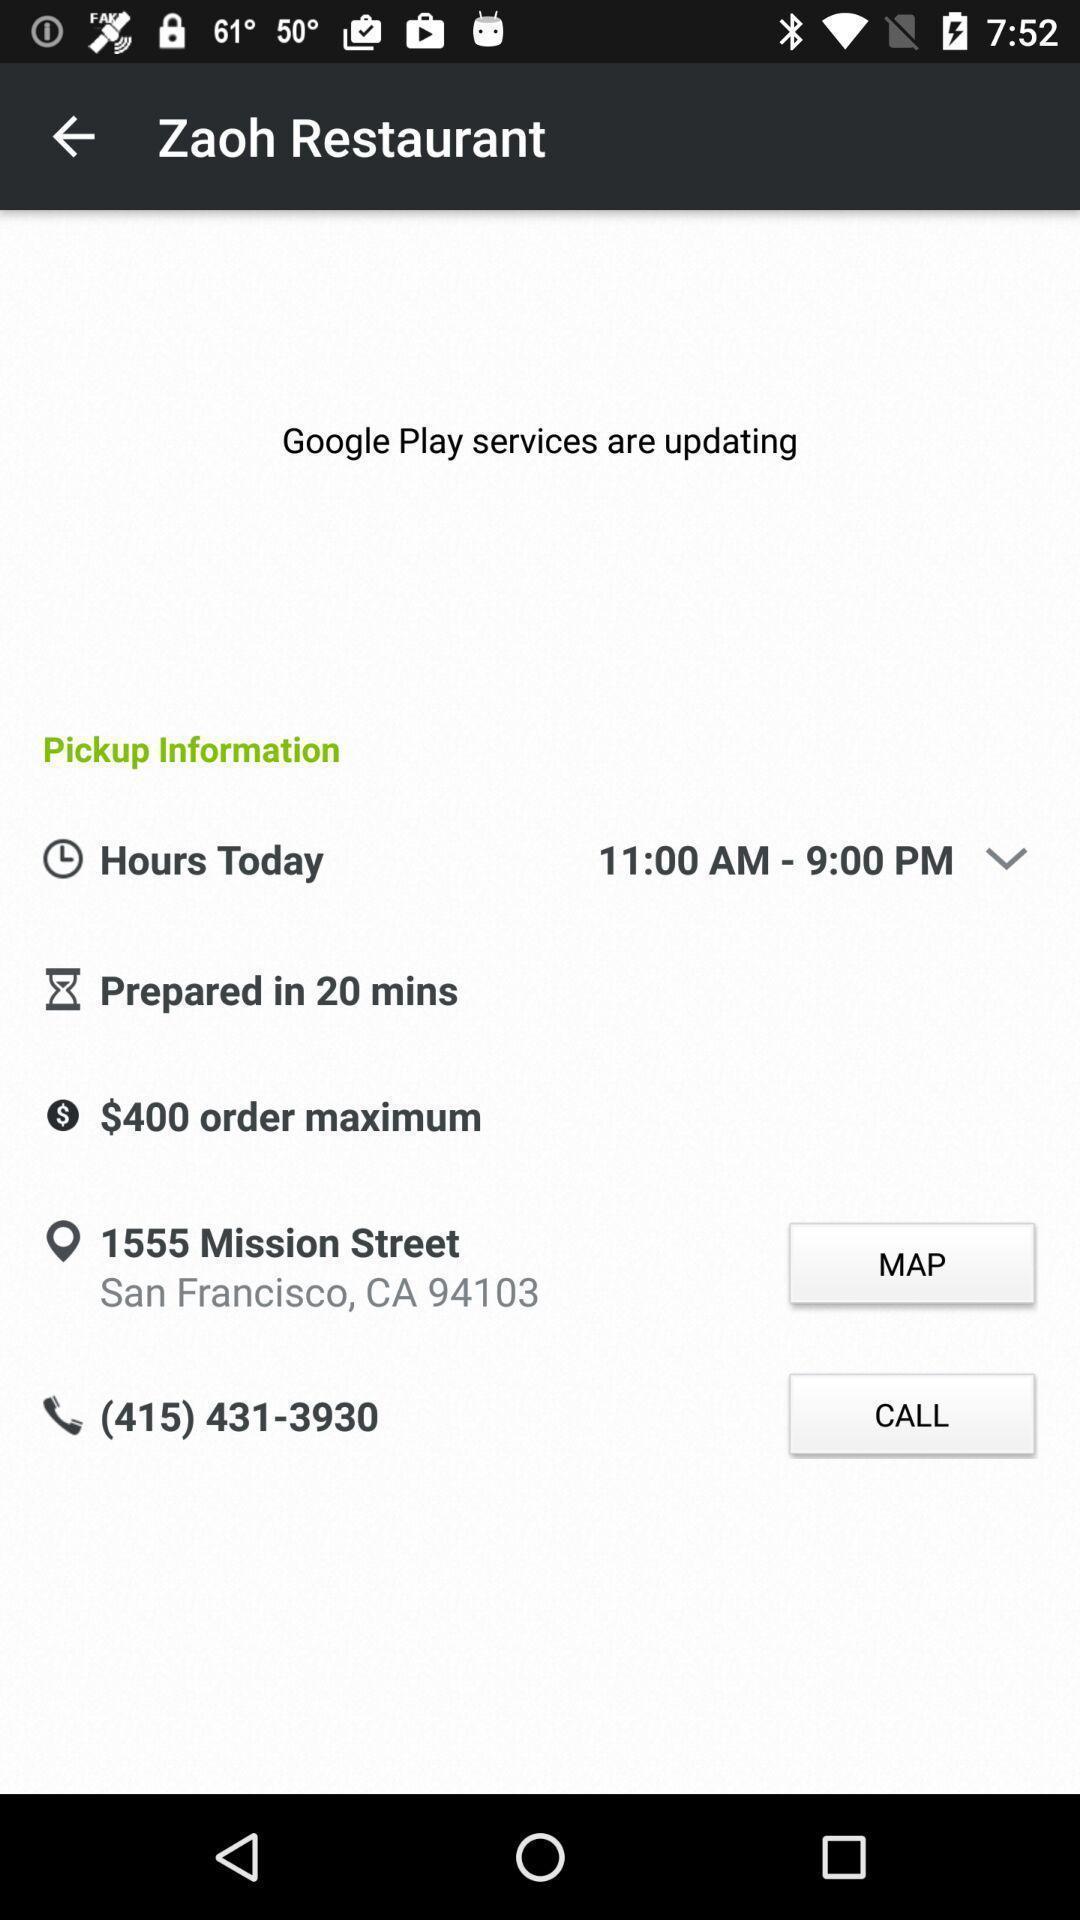What is the overall content of this screenshot? Page shows the details of restaurant timings and price. 